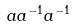<formula> <loc_0><loc_0><loc_500><loc_500>a a ^ { - 1 } a ^ { - 1 }</formula> 